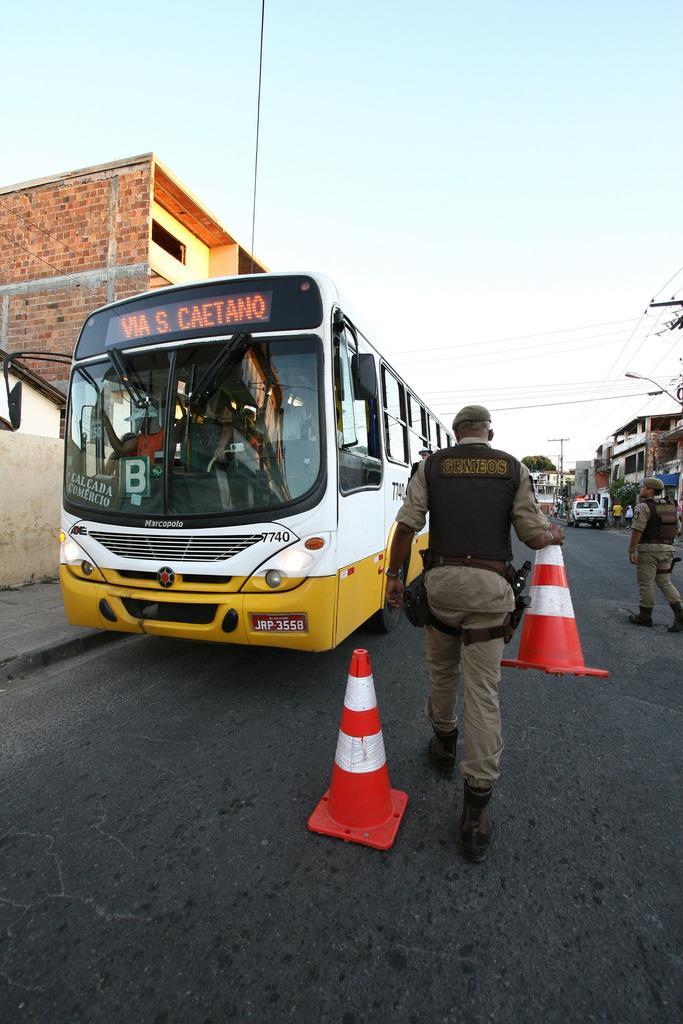Can you describe this image briefly? In this picture we can see a man is holding a traffic cone and another person is walking. On the road, there are vehicles and other traffic cone. On the left and right side of the image there are buildings. On the right side of the person, there are cables. At the top of the image, there is the sky. 